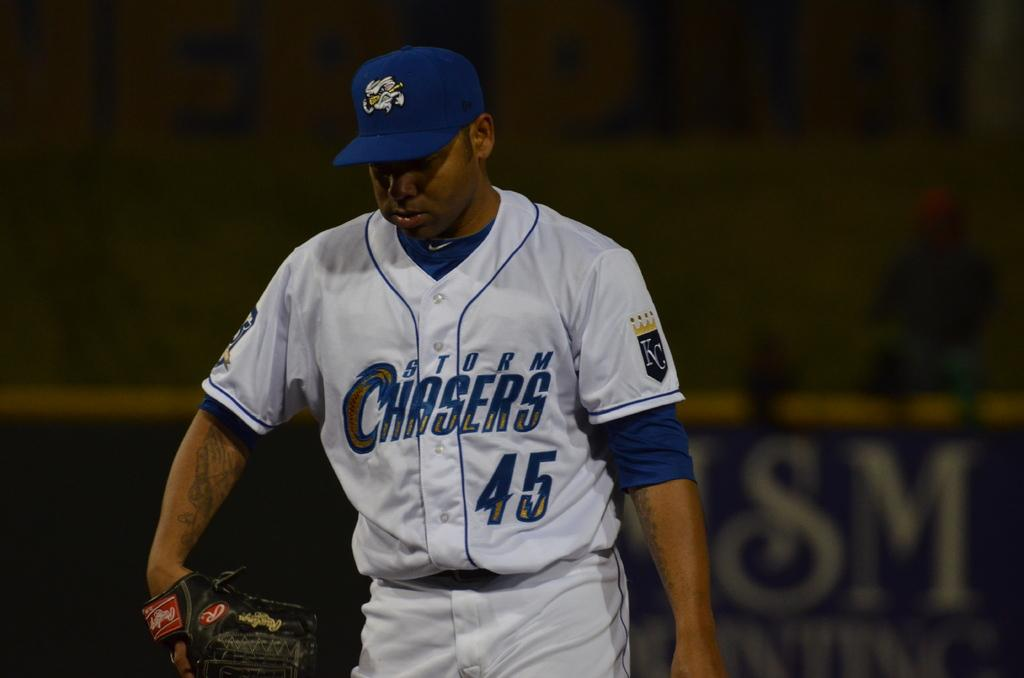Provide a one-sentence caption for the provided image. Kansas City Royals player 45 had a Storm Chasers logo on the front of his jersey as he headed onto the field with his glove. 